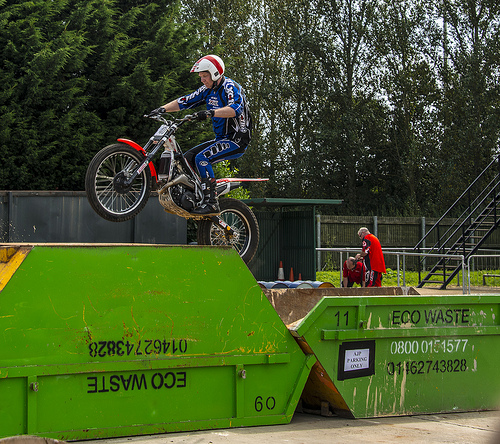<image>
Is the motorbike in front of the dumpster? No. The motorbike is not in front of the dumpster. The spatial positioning shows a different relationship between these objects. 